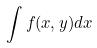<formula> <loc_0><loc_0><loc_500><loc_500>\int f ( x , y ) d x</formula> 